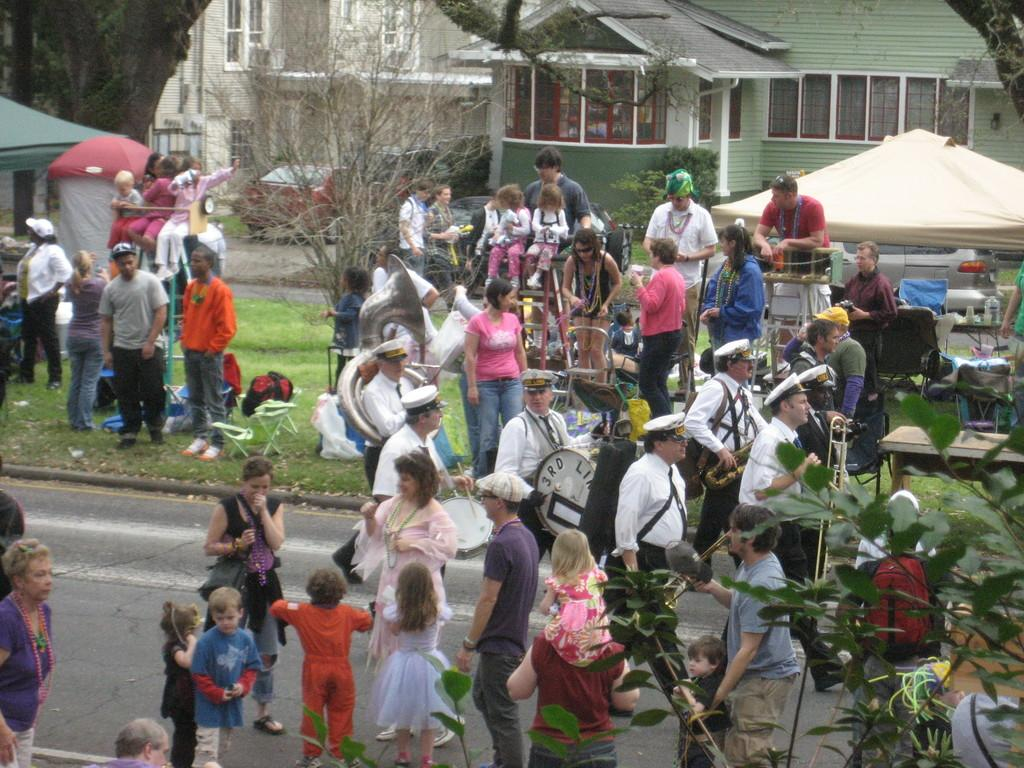How many people are in the image? There are people present in the image. What are the people doing in the image? There is a group of people playing musical instruments. What type of surface can be seen in the image? There is grass in the image. What type of seating is available in the image? There are chairs in the image. What type of temporary shelter is present in the image? There are tents in the image. What type of vegetation is visible in the image? There are trees in the image. What can be seen in the background of the image? There are vehicles and buildings in the background of the image. What type of net is being used to catch fish in the image? There is no net or fishing activity present in the image. What type of sticks are being used to stir the campfire in the image? There is no campfire or sticks present in the image. 